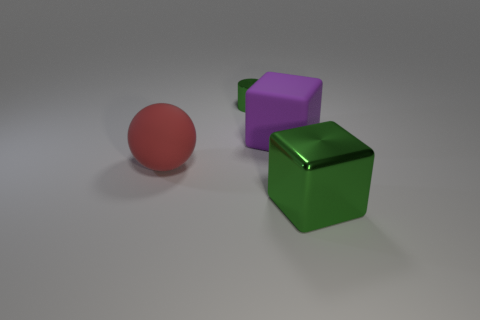What materials do the objects in the image seem to be made of? The objects in the image appear to have different textures. The green cube has a reflective metallic finish, the red sphere looks like it has a matte surface, and the purple cube seems to have a slightly glossy plastic appearance. 